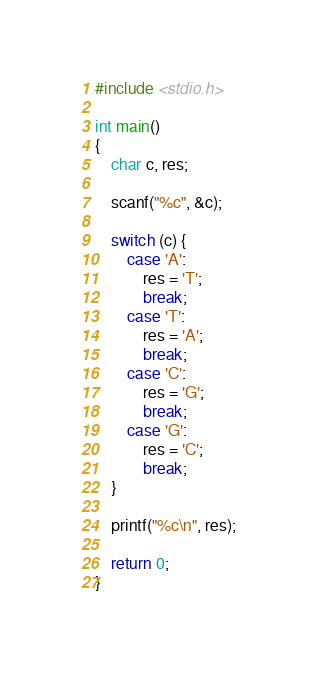Convert code to text. <code><loc_0><loc_0><loc_500><loc_500><_C_>#include <stdio.h>

int main()
{
    char c, res;

    scanf("%c", &c);

    switch (c) {
        case 'A':
            res = 'T';
            break;
        case 'T':
            res = 'A';
            break;
        case 'C':
            res = 'G';
            break;
        case 'G':
            res = 'C';
            break;
    }

    printf("%c\n", res);

    return 0;
}
</code> 